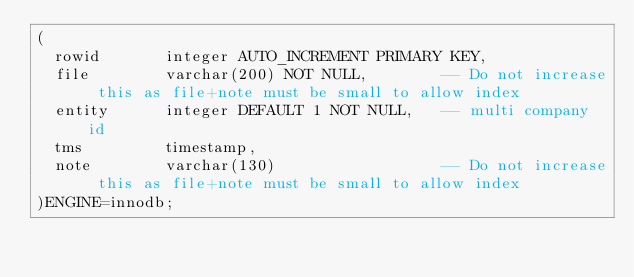<code> <loc_0><loc_0><loc_500><loc_500><_SQL_>(
  rowid       integer AUTO_INCREMENT PRIMARY KEY,
  file        varchar(200) NOT NULL,        -- Do not increase this as file+note must be small to allow index
  entity      integer DEFAULT 1 NOT NULL,	-- multi company id
  tms         timestamp,  
  note        varchar(130)                  -- Do not increase this as file+note must be small to allow index
)ENGINE=innodb;
</code> 